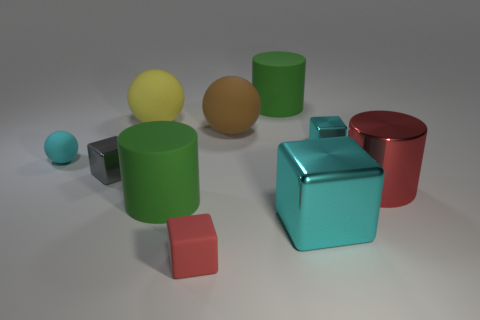What number of other things are there of the same color as the shiny cylinder?
Your answer should be compact. 1. What shape is the brown thing?
Offer a terse response. Sphere. There is a big red cylinder that is to the right of the green cylinder in front of the large cylinder that is behind the red cylinder; what is its material?
Ensure brevity in your answer.  Metal. Is the number of tiny gray shiny cubes behind the yellow thing greater than the number of small cyan spheres?
Ensure brevity in your answer.  No. There is a brown ball that is the same size as the yellow object; what is it made of?
Your answer should be very brief. Rubber. Are there any gray rubber cylinders of the same size as the red cylinder?
Keep it short and to the point. No. There is a cyan shiny object that is behind the tiny cyan matte ball; what is its size?
Ensure brevity in your answer.  Small. What is the size of the yellow object?
Ensure brevity in your answer.  Large. What number of spheres are either red matte things or small gray objects?
Offer a terse response. 0. What is the size of the yellow thing that is made of the same material as the brown ball?
Offer a very short reply. Large. 